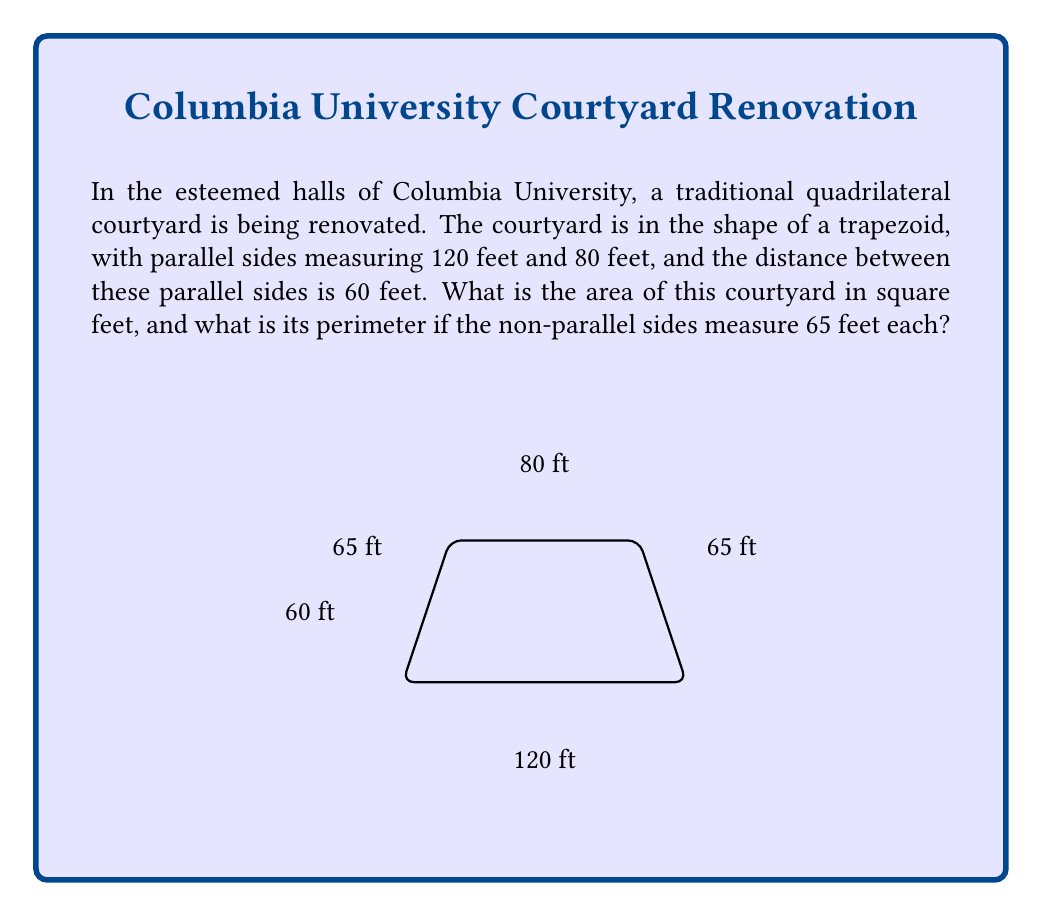Solve this math problem. Let us approach this problem systematically, befitting the rigorous academic traditions of Columbia University.

1. Area of the trapezoid:
   The formula for the area of a trapezoid is:
   $$A = \frac{1}{2}(b_1 + b_2)h$$
   where $b_1$ and $b_2$ are the lengths of the parallel sides, and $h$ is the height.

   Substituting our values:
   $$A = \frac{1}{2}(120 + 80) \times 60$$
   $$A = \frac{1}{2} \times 200 \times 60$$
   $$A = 100 \times 60 = 6000$$

2. Perimeter of the trapezoid:
   The perimeter is the sum of all sides. We know the parallel sides (120 ft and 80 ft) and the non-parallel sides (65 ft each).

   $$P = 120 + 80 + 65 + 65$$
   $$P = 200 + 130 = 330$$

Thus, we have calculated both the area and perimeter of this classical geometric shape.
Answer: The area of the courtyard is 6000 square feet, and its perimeter is 330 feet. 